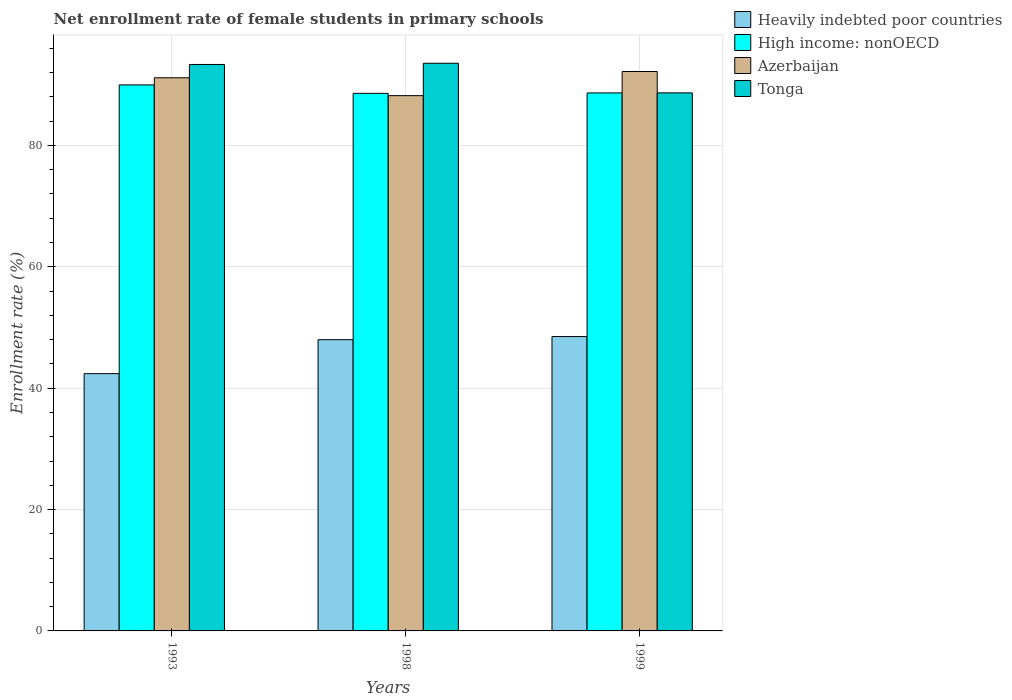Are the number of bars per tick equal to the number of legend labels?
Provide a short and direct response. Yes. How many bars are there on the 1st tick from the right?
Your answer should be very brief. 4. What is the label of the 3rd group of bars from the left?
Provide a short and direct response. 1999. What is the net enrollment rate of female students in primary schools in Tonga in 1999?
Offer a very short reply. 88.66. Across all years, what is the maximum net enrollment rate of female students in primary schools in High income: nonOECD?
Keep it short and to the point. 89.97. Across all years, what is the minimum net enrollment rate of female students in primary schools in Azerbaijan?
Provide a short and direct response. 88.2. In which year was the net enrollment rate of female students in primary schools in Azerbaijan minimum?
Ensure brevity in your answer.  1998. What is the total net enrollment rate of female students in primary schools in Tonga in the graph?
Provide a short and direct response. 275.55. What is the difference between the net enrollment rate of female students in primary schools in Azerbaijan in 1998 and that in 1999?
Make the answer very short. -3.98. What is the difference between the net enrollment rate of female students in primary schools in Azerbaijan in 1993 and the net enrollment rate of female students in primary schools in High income: nonOECD in 1998?
Your response must be concise. 2.57. What is the average net enrollment rate of female students in primary schools in Heavily indebted poor countries per year?
Ensure brevity in your answer.  46.3. In the year 1993, what is the difference between the net enrollment rate of female students in primary schools in High income: nonOECD and net enrollment rate of female students in primary schools in Azerbaijan?
Your response must be concise. -1.18. In how many years, is the net enrollment rate of female students in primary schools in High income: nonOECD greater than 28 %?
Ensure brevity in your answer.  3. What is the ratio of the net enrollment rate of female students in primary schools in Heavily indebted poor countries in 1998 to that in 1999?
Provide a succinct answer. 0.99. Is the net enrollment rate of female students in primary schools in Heavily indebted poor countries in 1998 less than that in 1999?
Make the answer very short. Yes. What is the difference between the highest and the second highest net enrollment rate of female students in primary schools in Tonga?
Offer a very short reply. 0.2. What is the difference between the highest and the lowest net enrollment rate of female students in primary schools in High income: nonOECD?
Provide a short and direct response. 1.39. What does the 4th bar from the left in 1993 represents?
Offer a terse response. Tonga. What does the 2nd bar from the right in 1999 represents?
Make the answer very short. Azerbaijan. Is it the case that in every year, the sum of the net enrollment rate of female students in primary schools in Azerbaijan and net enrollment rate of female students in primary schools in Tonga is greater than the net enrollment rate of female students in primary schools in High income: nonOECD?
Offer a terse response. Yes. How many bars are there?
Your answer should be compact. 12. Are all the bars in the graph horizontal?
Your answer should be very brief. No. What is the difference between two consecutive major ticks on the Y-axis?
Make the answer very short. 20. Does the graph contain any zero values?
Make the answer very short. No. Does the graph contain grids?
Ensure brevity in your answer.  Yes. How many legend labels are there?
Make the answer very short. 4. How are the legend labels stacked?
Your answer should be very brief. Vertical. What is the title of the graph?
Give a very brief answer. Net enrollment rate of female students in primary schools. Does "Guinea" appear as one of the legend labels in the graph?
Your answer should be compact. No. What is the label or title of the X-axis?
Provide a succinct answer. Years. What is the label or title of the Y-axis?
Ensure brevity in your answer.  Enrollment rate (%). What is the Enrollment rate (%) in Heavily indebted poor countries in 1993?
Offer a very short reply. 42.39. What is the Enrollment rate (%) of High income: nonOECD in 1993?
Your response must be concise. 89.97. What is the Enrollment rate (%) in Azerbaijan in 1993?
Ensure brevity in your answer.  91.15. What is the Enrollment rate (%) in Tonga in 1993?
Your answer should be compact. 93.34. What is the Enrollment rate (%) of Heavily indebted poor countries in 1998?
Your response must be concise. 47.99. What is the Enrollment rate (%) of High income: nonOECD in 1998?
Provide a short and direct response. 88.58. What is the Enrollment rate (%) in Azerbaijan in 1998?
Offer a very short reply. 88.2. What is the Enrollment rate (%) of Tonga in 1998?
Ensure brevity in your answer.  93.54. What is the Enrollment rate (%) in Heavily indebted poor countries in 1999?
Give a very brief answer. 48.51. What is the Enrollment rate (%) of High income: nonOECD in 1999?
Ensure brevity in your answer.  88.65. What is the Enrollment rate (%) in Azerbaijan in 1999?
Ensure brevity in your answer.  92.18. What is the Enrollment rate (%) in Tonga in 1999?
Provide a succinct answer. 88.66. Across all years, what is the maximum Enrollment rate (%) of Heavily indebted poor countries?
Your response must be concise. 48.51. Across all years, what is the maximum Enrollment rate (%) in High income: nonOECD?
Your answer should be very brief. 89.97. Across all years, what is the maximum Enrollment rate (%) of Azerbaijan?
Give a very brief answer. 92.18. Across all years, what is the maximum Enrollment rate (%) of Tonga?
Give a very brief answer. 93.54. Across all years, what is the minimum Enrollment rate (%) of Heavily indebted poor countries?
Your response must be concise. 42.39. Across all years, what is the minimum Enrollment rate (%) of High income: nonOECD?
Give a very brief answer. 88.58. Across all years, what is the minimum Enrollment rate (%) of Azerbaijan?
Your answer should be very brief. 88.2. Across all years, what is the minimum Enrollment rate (%) in Tonga?
Ensure brevity in your answer.  88.66. What is the total Enrollment rate (%) in Heavily indebted poor countries in the graph?
Your answer should be compact. 138.89. What is the total Enrollment rate (%) in High income: nonOECD in the graph?
Your answer should be compact. 267.21. What is the total Enrollment rate (%) in Azerbaijan in the graph?
Offer a terse response. 271.54. What is the total Enrollment rate (%) of Tonga in the graph?
Ensure brevity in your answer.  275.55. What is the difference between the Enrollment rate (%) of Heavily indebted poor countries in 1993 and that in 1998?
Keep it short and to the point. -5.59. What is the difference between the Enrollment rate (%) of High income: nonOECD in 1993 and that in 1998?
Give a very brief answer. 1.39. What is the difference between the Enrollment rate (%) of Azerbaijan in 1993 and that in 1998?
Provide a short and direct response. 2.95. What is the difference between the Enrollment rate (%) in Tonga in 1993 and that in 1998?
Offer a very short reply. -0.2. What is the difference between the Enrollment rate (%) in Heavily indebted poor countries in 1993 and that in 1999?
Make the answer very short. -6.11. What is the difference between the Enrollment rate (%) in High income: nonOECD in 1993 and that in 1999?
Provide a short and direct response. 1.32. What is the difference between the Enrollment rate (%) in Azerbaijan in 1993 and that in 1999?
Make the answer very short. -1.03. What is the difference between the Enrollment rate (%) of Tonga in 1993 and that in 1999?
Keep it short and to the point. 4.68. What is the difference between the Enrollment rate (%) of Heavily indebted poor countries in 1998 and that in 1999?
Offer a very short reply. -0.52. What is the difference between the Enrollment rate (%) in High income: nonOECD in 1998 and that in 1999?
Your response must be concise. -0.07. What is the difference between the Enrollment rate (%) in Azerbaijan in 1998 and that in 1999?
Your response must be concise. -3.98. What is the difference between the Enrollment rate (%) in Tonga in 1998 and that in 1999?
Give a very brief answer. 4.88. What is the difference between the Enrollment rate (%) of Heavily indebted poor countries in 1993 and the Enrollment rate (%) of High income: nonOECD in 1998?
Your answer should be very brief. -46.19. What is the difference between the Enrollment rate (%) in Heavily indebted poor countries in 1993 and the Enrollment rate (%) in Azerbaijan in 1998?
Offer a very short reply. -45.81. What is the difference between the Enrollment rate (%) of Heavily indebted poor countries in 1993 and the Enrollment rate (%) of Tonga in 1998?
Your response must be concise. -51.15. What is the difference between the Enrollment rate (%) of High income: nonOECD in 1993 and the Enrollment rate (%) of Azerbaijan in 1998?
Make the answer very short. 1.77. What is the difference between the Enrollment rate (%) in High income: nonOECD in 1993 and the Enrollment rate (%) in Tonga in 1998?
Keep it short and to the point. -3.57. What is the difference between the Enrollment rate (%) in Azerbaijan in 1993 and the Enrollment rate (%) in Tonga in 1998?
Your response must be concise. -2.39. What is the difference between the Enrollment rate (%) in Heavily indebted poor countries in 1993 and the Enrollment rate (%) in High income: nonOECD in 1999?
Make the answer very short. -46.26. What is the difference between the Enrollment rate (%) in Heavily indebted poor countries in 1993 and the Enrollment rate (%) in Azerbaijan in 1999?
Your answer should be very brief. -49.79. What is the difference between the Enrollment rate (%) in Heavily indebted poor countries in 1993 and the Enrollment rate (%) in Tonga in 1999?
Ensure brevity in your answer.  -46.27. What is the difference between the Enrollment rate (%) of High income: nonOECD in 1993 and the Enrollment rate (%) of Azerbaijan in 1999?
Make the answer very short. -2.21. What is the difference between the Enrollment rate (%) of High income: nonOECD in 1993 and the Enrollment rate (%) of Tonga in 1999?
Make the answer very short. 1.31. What is the difference between the Enrollment rate (%) in Azerbaijan in 1993 and the Enrollment rate (%) in Tonga in 1999?
Keep it short and to the point. 2.49. What is the difference between the Enrollment rate (%) in Heavily indebted poor countries in 1998 and the Enrollment rate (%) in High income: nonOECD in 1999?
Offer a very short reply. -40.66. What is the difference between the Enrollment rate (%) of Heavily indebted poor countries in 1998 and the Enrollment rate (%) of Azerbaijan in 1999?
Provide a short and direct response. -44.19. What is the difference between the Enrollment rate (%) in Heavily indebted poor countries in 1998 and the Enrollment rate (%) in Tonga in 1999?
Your answer should be very brief. -40.67. What is the difference between the Enrollment rate (%) in High income: nonOECD in 1998 and the Enrollment rate (%) in Azerbaijan in 1999?
Provide a succinct answer. -3.6. What is the difference between the Enrollment rate (%) of High income: nonOECD in 1998 and the Enrollment rate (%) of Tonga in 1999?
Your answer should be very brief. -0.08. What is the difference between the Enrollment rate (%) in Azerbaijan in 1998 and the Enrollment rate (%) in Tonga in 1999?
Make the answer very short. -0.46. What is the average Enrollment rate (%) of Heavily indebted poor countries per year?
Ensure brevity in your answer.  46.3. What is the average Enrollment rate (%) in High income: nonOECD per year?
Your answer should be compact. 89.07. What is the average Enrollment rate (%) of Azerbaijan per year?
Provide a short and direct response. 90.51. What is the average Enrollment rate (%) in Tonga per year?
Provide a succinct answer. 91.85. In the year 1993, what is the difference between the Enrollment rate (%) in Heavily indebted poor countries and Enrollment rate (%) in High income: nonOECD?
Your answer should be very brief. -47.58. In the year 1993, what is the difference between the Enrollment rate (%) in Heavily indebted poor countries and Enrollment rate (%) in Azerbaijan?
Your answer should be compact. -48.76. In the year 1993, what is the difference between the Enrollment rate (%) of Heavily indebted poor countries and Enrollment rate (%) of Tonga?
Make the answer very short. -50.95. In the year 1993, what is the difference between the Enrollment rate (%) of High income: nonOECD and Enrollment rate (%) of Azerbaijan?
Give a very brief answer. -1.18. In the year 1993, what is the difference between the Enrollment rate (%) of High income: nonOECD and Enrollment rate (%) of Tonga?
Offer a very short reply. -3.37. In the year 1993, what is the difference between the Enrollment rate (%) of Azerbaijan and Enrollment rate (%) of Tonga?
Your answer should be very brief. -2.19. In the year 1998, what is the difference between the Enrollment rate (%) in Heavily indebted poor countries and Enrollment rate (%) in High income: nonOECD?
Your response must be concise. -40.59. In the year 1998, what is the difference between the Enrollment rate (%) of Heavily indebted poor countries and Enrollment rate (%) of Azerbaijan?
Provide a short and direct response. -40.22. In the year 1998, what is the difference between the Enrollment rate (%) of Heavily indebted poor countries and Enrollment rate (%) of Tonga?
Provide a succinct answer. -45.55. In the year 1998, what is the difference between the Enrollment rate (%) of High income: nonOECD and Enrollment rate (%) of Azerbaijan?
Offer a very short reply. 0.38. In the year 1998, what is the difference between the Enrollment rate (%) in High income: nonOECD and Enrollment rate (%) in Tonga?
Keep it short and to the point. -4.96. In the year 1998, what is the difference between the Enrollment rate (%) of Azerbaijan and Enrollment rate (%) of Tonga?
Your response must be concise. -5.34. In the year 1999, what is the difference between the Enrollment rate (%) of Heavily indebted poor countries and Enrollment rate (%) of High income: nonOECD?
Ensure brevity in your answer.  -40.14. In the year 1999, what is the difference between the Enrollment rate (%) of Heavily indebted poor countries and Enrollment rate (%) of Azerbaijan?
Give a very brief answer. -43.67. In the year 1999, what is the difference between the Enrollment rate (%) of Heavily indebted poor countries and Enrollment rate (%) of Tonga?
Your response must be concise. -40.16. In the year 1999, what is the difference between the Enrollment rate (%) of High income: nonOECD and Enrollment rate (%) of Azerbaijan?
Keep it short and to the point. -3.53. In the year 1999, what is the difference between the Enrollment rate (%) of High income: nonOECD and Enrollment rate (%) of Tonga?
Offer a very short reply. -0.01. In the year 1999, what is the difference between the Enrollment rate (%) in Azerbaijan and Enrollment rate (%) in Tonga?
Keep it short and to the point. 3.52. What is the ratio of the Enrollment rate (%) of Heavily indebted poor countries in 1993 to that in 1998?
Make the answer very short. 0.88. What is the ratio of the Enrollment rate (%) of High income: nonOECD in 1993 to that in 1998?
Your answer should be compact. 1.02. What is the ratio of the Enrollment rate (%) of Azerbaijan in 1993 to that in 1998?
Keep it short and to the point. 1.03. What is the ratio of the Enrollment rate (%) in Tonga in 1993 to that in 1998?
Your response must be concise. 1. What is the ratio of the Enrollment rate (%) of Heavily indebted poor countries in 1993 to that in 1999?
Provide a short and direct response. 0.87. What is the ratio of the Enrollment rate (%) in High income: nonOECD in 1993 to that in 1999?
Provide a succinct answer. 1.01. What is the ratio of the Enrollment rate (%) of Tonga in 1993 to that in 1999?
Offer a very short reply. 1.05. What is the ratio of the Enrollment rate (%) of Heavily indebted poor countries in 1998 to that in 1999?
Ensure brevity in your answer.  0.99. What is the ratio of the Enrollment rate (%) of High income: nonOECD in 1998 to that in 1999?
Ensure brevity in your answer.  1. What is the ratio of the Enrollment rate (%) in Azerbaijan in 1998 to that in 1999?
Ensure brevity in your answer.  0.96. What is the ratio of the Enrollment rate (%) in Tonga in 1998 to that in 1999?
Offer a very short reply. 1.05. What is the difference between the highest and the second highest Enrollment rate (%) in Heavily indebted poor countries?
Offer a terse response. 0.52. What is the difference between the highest and the second highest Enrollment rate (%) of High income: nonOECD?
Ensure brevity in your answer.  1.32. What is the difference between the highest and the second highest Enrollment rate (%) in Azerbaijan?
Keep it short and to the point. 1.03. What is the difference between the highest and the second highest Enrollment rate (%) of Tonga?
Provide a short and direct response. 0.2. What is the difference between the highest and the lowest Enrollment rate (%) of Heavily indebted poor countries?
Your response must be concise. 6.11. What is the difference between the highest and the lowest Enrollment rate (%) in High income: nonOECD?
Your response must be concise. 1.39. What is the difference between the highest and the lowest Enrollment rate (%) of Azerbaijan?
Offer a very short reply. 3.98. What is the difference between the highest and the lowest Enrollment rate (%) in Tonga?
Keep it short and to the point. 4.88. 